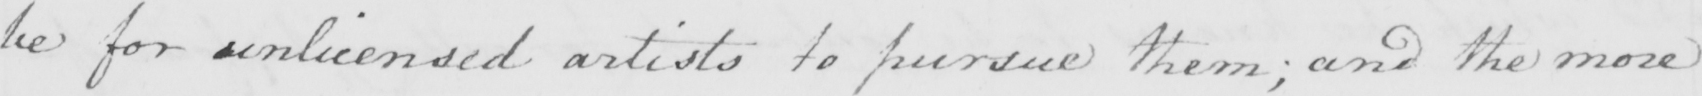Transcribe the text shown in this historical manuscript line. be for unlicensed artists to pursue them ; and the more 